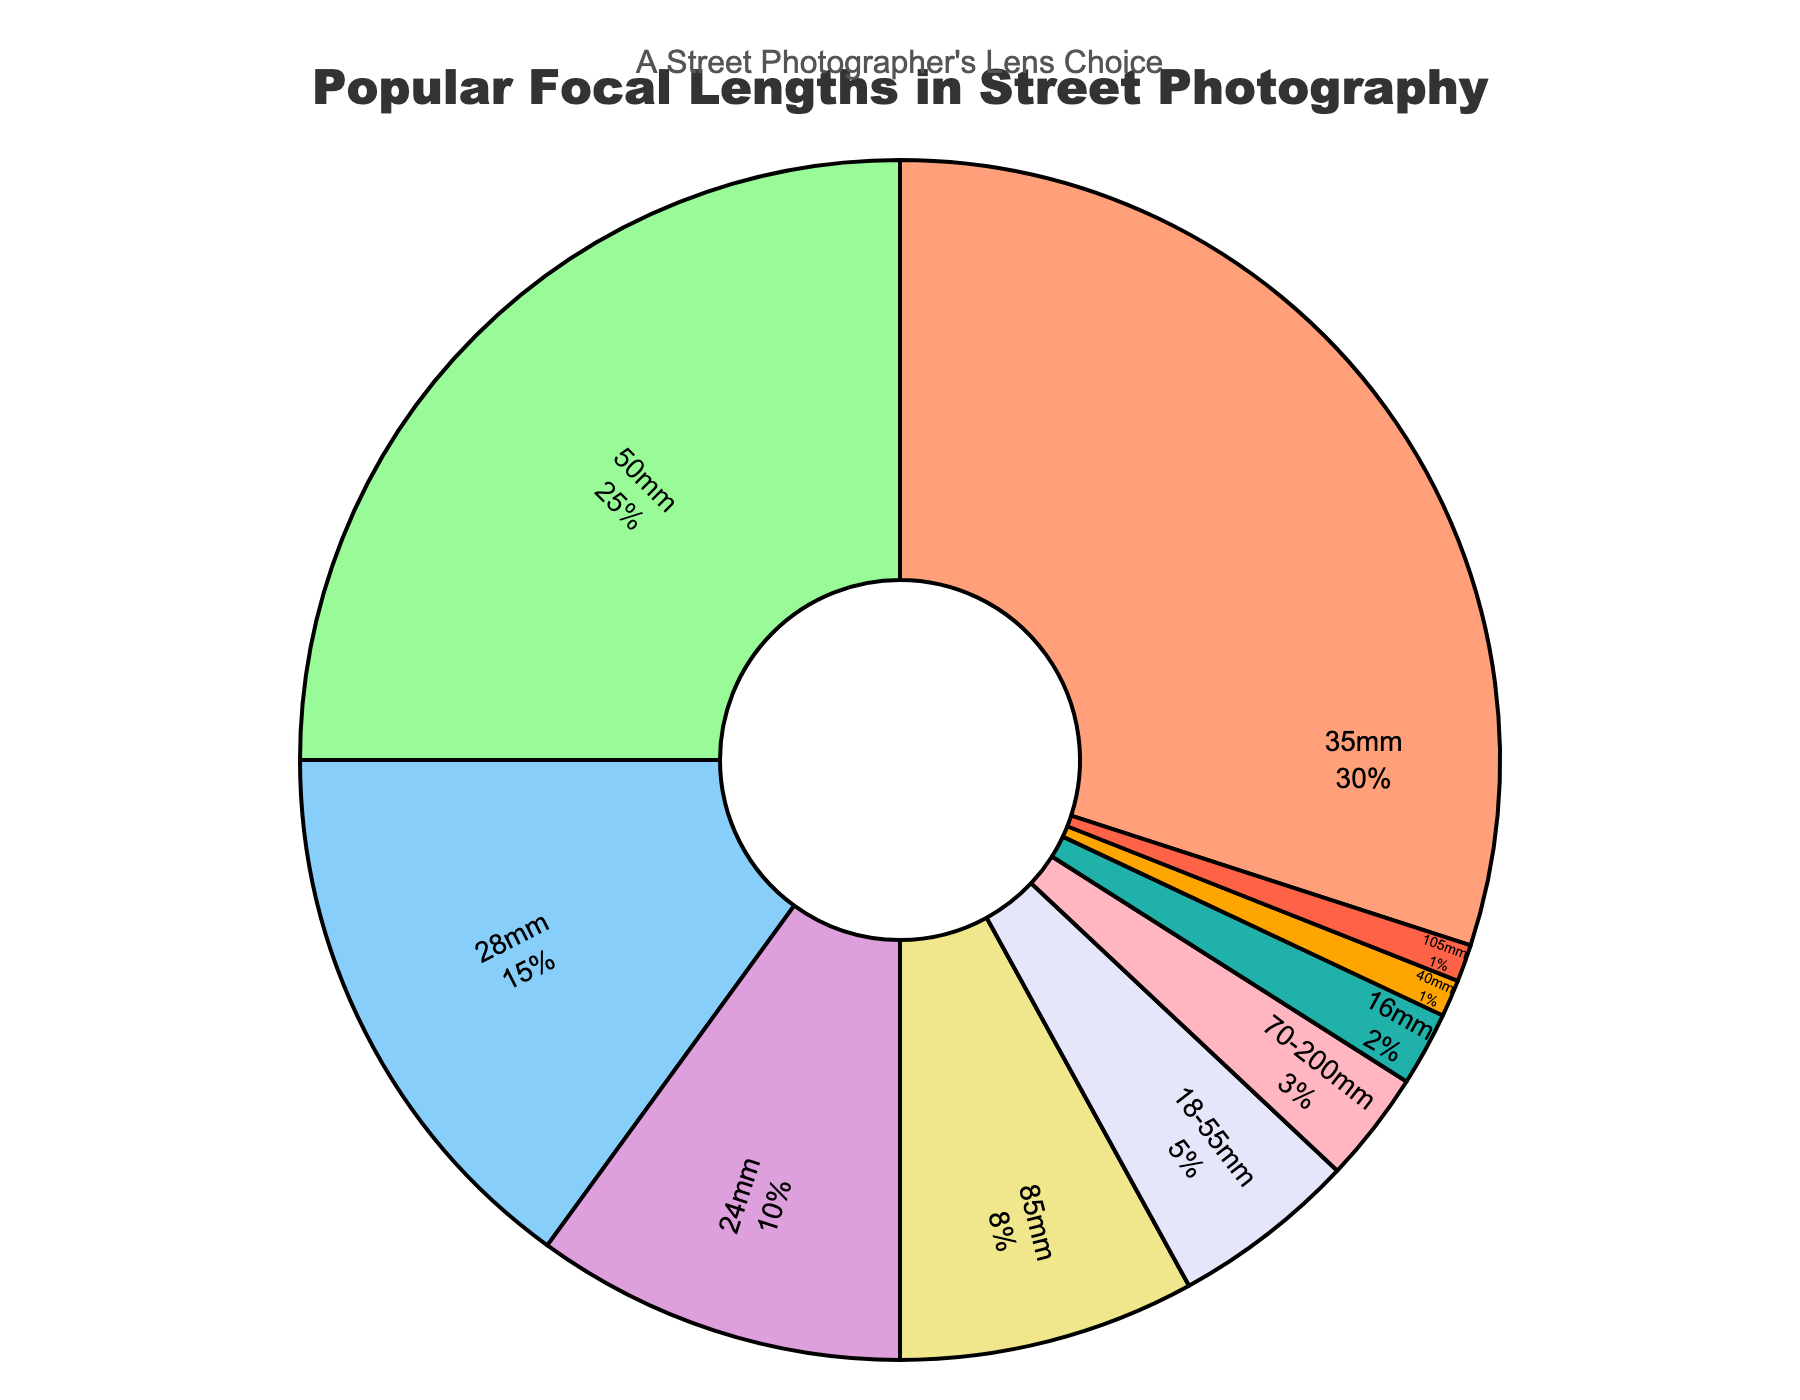Which focal length is the most popular in street photography? The chart shows that 35mm has the largest segment, indicating it is the most popular.
Answer: 35mm What percentage of street photographers use a 50mm lens? Locate the segment labeled "50mm" on the chart. The label and the percentage displayed inside the segment indicate 25%.
Answer: 25% How much more popular is the 35mm lens compared to the 24mm lens? The chart shows 35mm at 30% and 24mm at 10%. Subtract the percentage of 24mm from 35mm (30 - 10).
Answer: 20% What is the total percentage of photographers using either 28mm or 85mm lenses? Sum the percentage values of 28mm and 85mm. The chart shows 15% for 28mm and 8% for 85mm (15 + 8).
Answer: 23% Which lenses are used by less than 5% of photographers? Identify segments with less than 5% labels. The chart indicates 70-200mm (3%), 16mm (2%), 40mm (1%), and 105mm (1%).
Answer: 70-200mm, 16mm, 40mm, 105mm How many lenses are used by at least 10% of photographers? Count the segments representing 10% or more. The chart shows segments for 35mm (30%), 50mm (25%), 28mm (15%), and 24mm (10%)—total four segments.
Answer: 4 How does the popularity of the 50mm lens compare to the 18-55mm lens? Find 50mm (25%) and 18-55mm (5%) on the chart. The 50mm lens is 20% more popular than the 18-55mm lens (25 - 5).
Answer: 20% more popular What is the combined percentage of all focal lengths except for the most popular one? Subtract the percentage of the most popular lens (35mm) from 100% (100 - 30).
Answer: 70% Which lens is slightly more preferred: the 85mm or the 24mm? Find 85mm (8%) and 24mm (10%) on the chart. The 24mm lens is slightly more preferred by 2% (10 - 8).
Answer: 24mm What is the median percentage value of the focal lengths used? List all percentages in ascending order: 1%, 1%, 2%, 3%, 5%, 8%, 10%, 15%, 25%, 30%. The median is the average of the 5th and 6th values (5 + 8) / 2.
Answer: 6.5% 